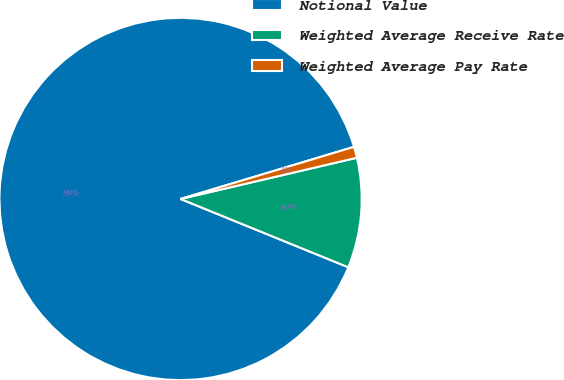Convert chart to OTSL. <chart><loc_0><loc_0><loc_500><loc_500><pie_chart><fcel>Notional Value<fcel>Weighted Average Receive Rate<fcel>Weighted Average Pay Rate<nl><fcel>89.21%<fcel>9.81%<fcel>0.99%<nl></chart> 